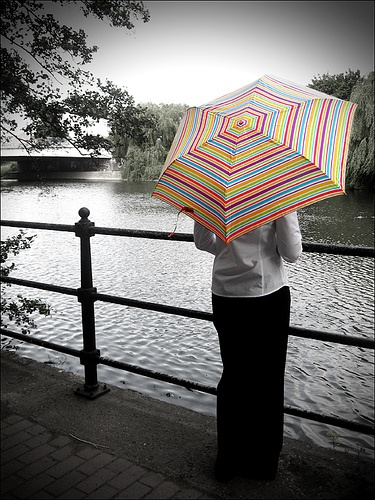Describe the objects in this image and their specific colors. I can see umbrella in black, lightgray, khaki, darkgray, and lightpink tones and people in black, gray, darkgray, and lightgray tones in this image. 